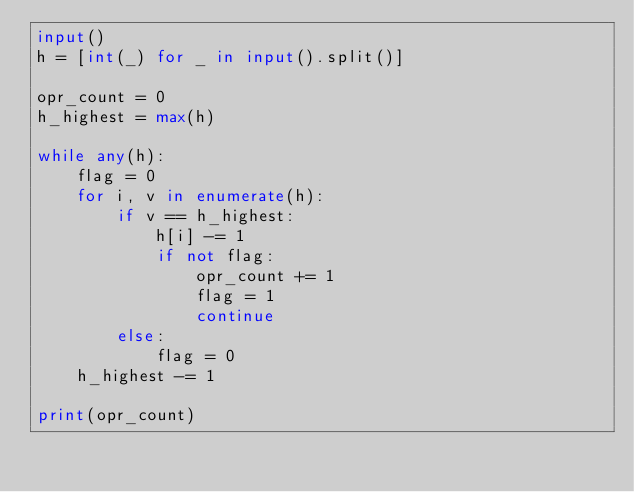Convert code to text. <code><loc_0><loc_0><loc_500><loc_500><_Python_>input()
h = [int(_) for _ in input().split()]

opr_count = 0
h_highest = max(h)

while any(h):
    flag = 0
    for i, v in enumerate(h):
        if v == h_highest:
            h[i] -= 1
            if not flag:
                opr_count += 1
                flag = 1
                continue
        else:
            flag = 0
    h_highest -= 1

print(opr_count)</code> 